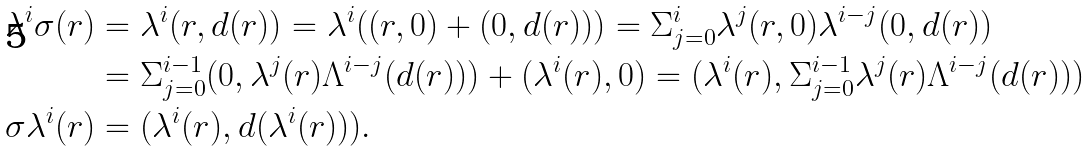Convert formula to latex. <formula><loc_0><loc_0><loc_500><loc_500>\lambda ^ { i } \sigma ( r ) & = \lambda ^ { i } ( r , d ( r ) ) = \lambda ^ { i } ( ( r , 0 ) + ( 0 , d ( r ) ) ) = \Sigma _ { j = 0 } ^ { i } \lambda ^ { j } ( r , 0 ) \lambda ^ { i - j } ( 0 , d ( r ) ) \\ & = \Sigma _ { j = 0 } ^ { i - 1 } ( 0 , \lambda ^ { j } ( r ) \Lambda ^ { i - j } ( d ( r ) ) ) + ( \lambda ^ { i } ( r ) , 0 ) = ( \lambda ^ { i } ( r ) , \Sigma _ { j = 0 } ^ { i - 1 } \lambda ^ { j } ( r ) \Lambda ^ { i - j } ( d ( r ) ) ) \\ \sigma \lambda ^ { i } ( r ) & = ( \lambda ^ { i } ( r ) , d ( \lambda ^ { i } ( r ) ) ) .</formula> 